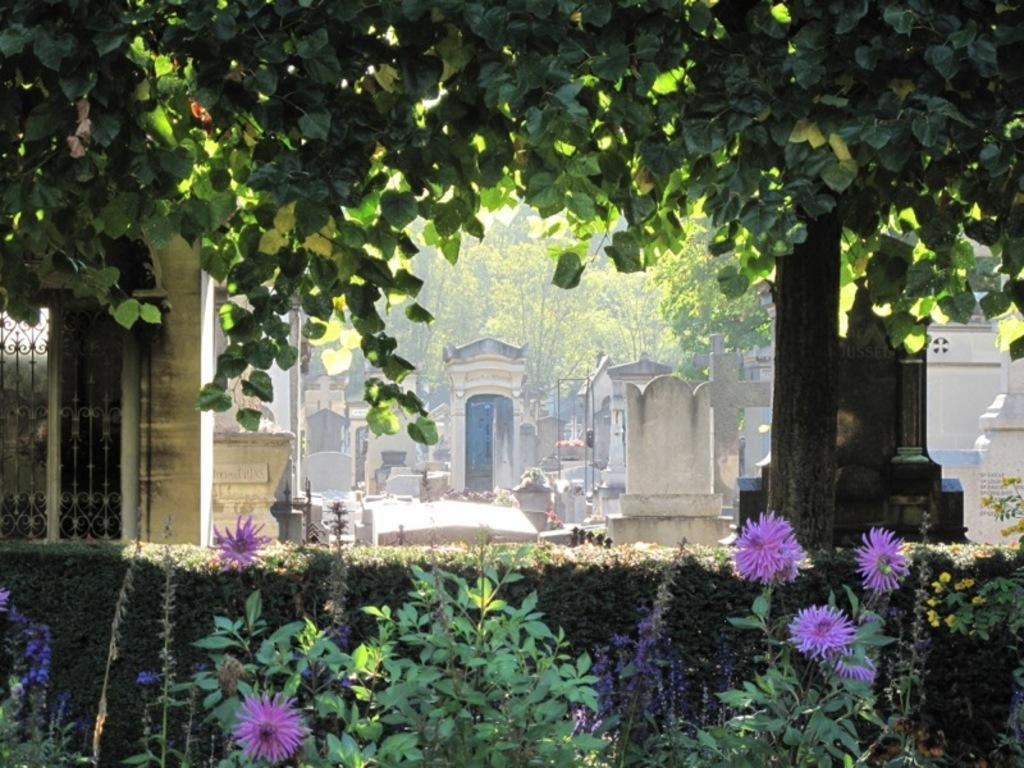What type of plants can be seen in the image? There are flowers, shrubs, and trees in the image. What else is present in the image besides plants? There are buildings in the image. Can you describe the types of plants in more detail? The image contains flowers, which are smaller and more colorful plants, shrubs, which are woody plants that are shorter than trees, and trees, which are tall plants with a woody trunk. What type of rod is used to cause the flowers to grow in the image? There is no rod present in the image, and the growth of flowers is a natural process that does not require any specific tools or devices. 